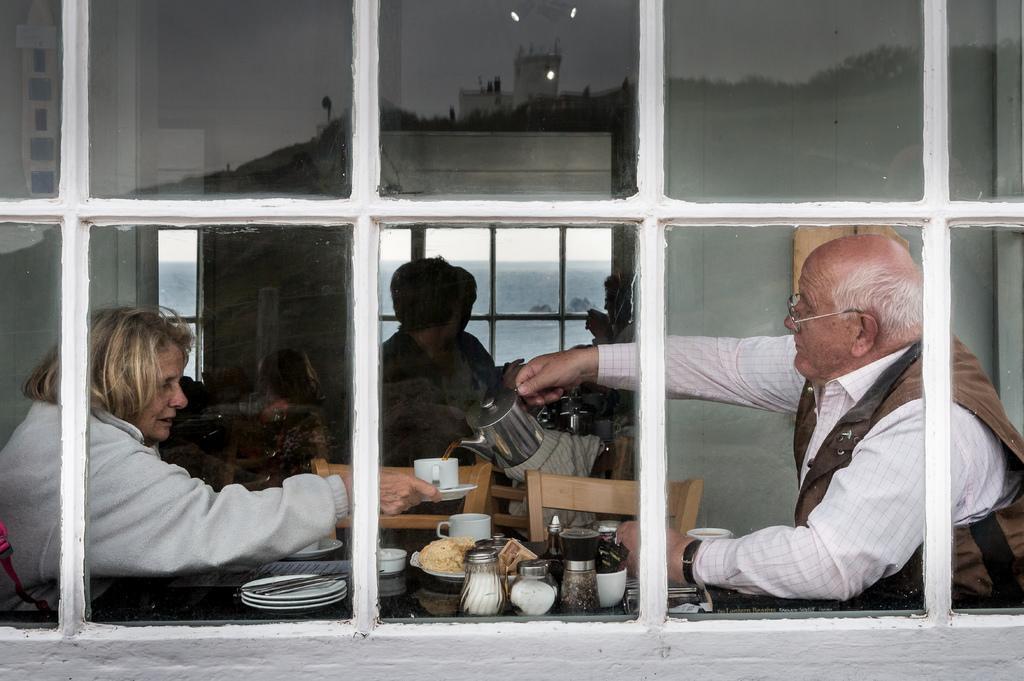In one or two sentences, can you explain what this image depicts? In this image we can see group of persons are sitting, in front there is a table, and plates, cups, and some objects on it, there is a window, there is a sky. 